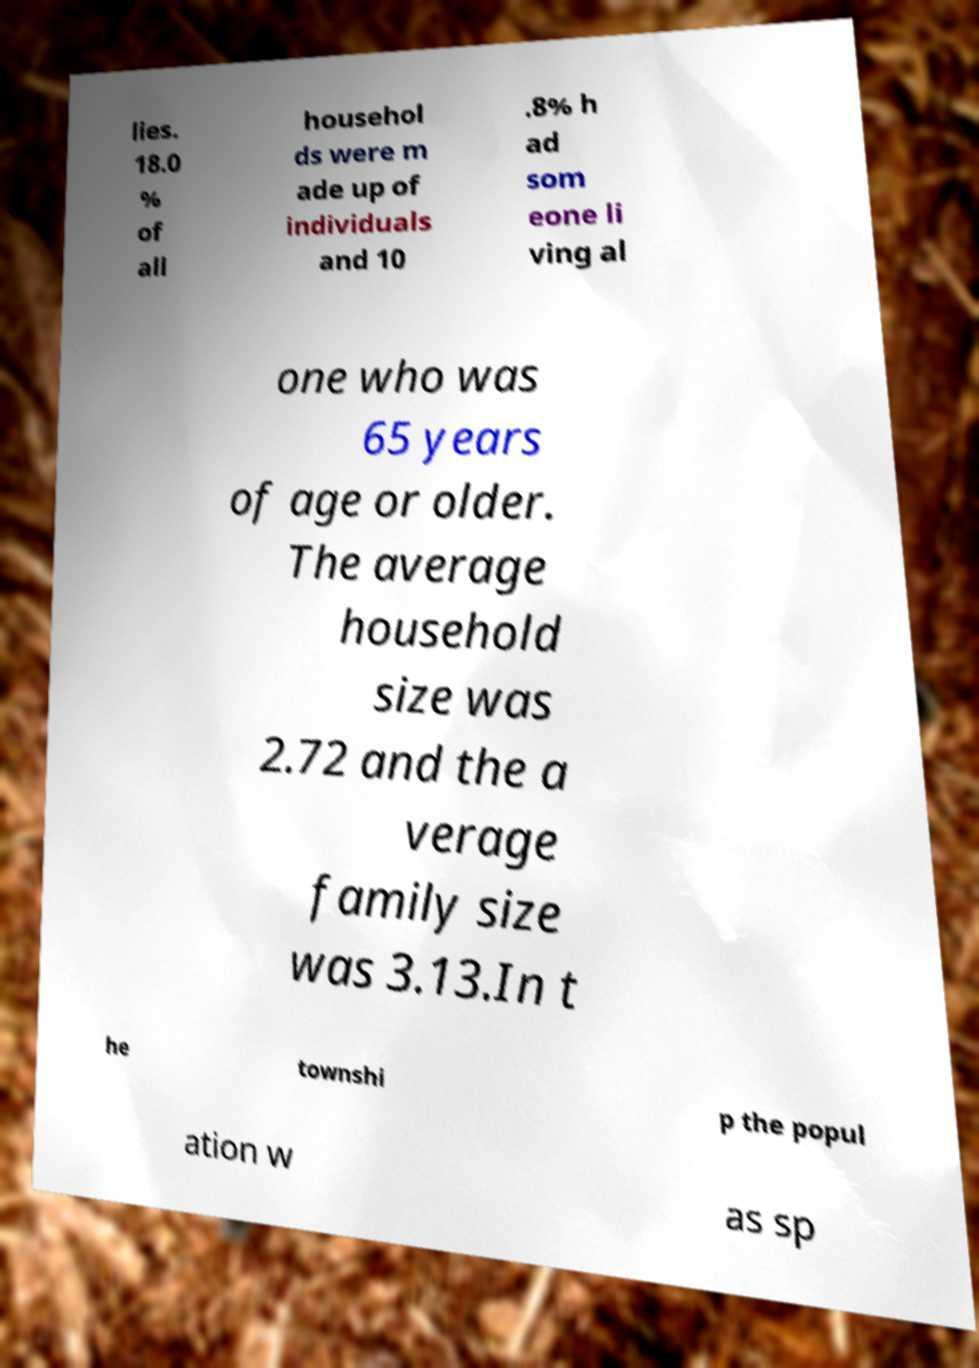Can you accurately transcribe the text from the provided image for me? lies. 18.0 % of all househol ds were m ade up of individuals and 10 .8% h ad som eone li ving al one who was 65 years of age or older. The average household size was 2.72 and the a verage family size was 3.13.In t he townshi p the popul ation w as sp 